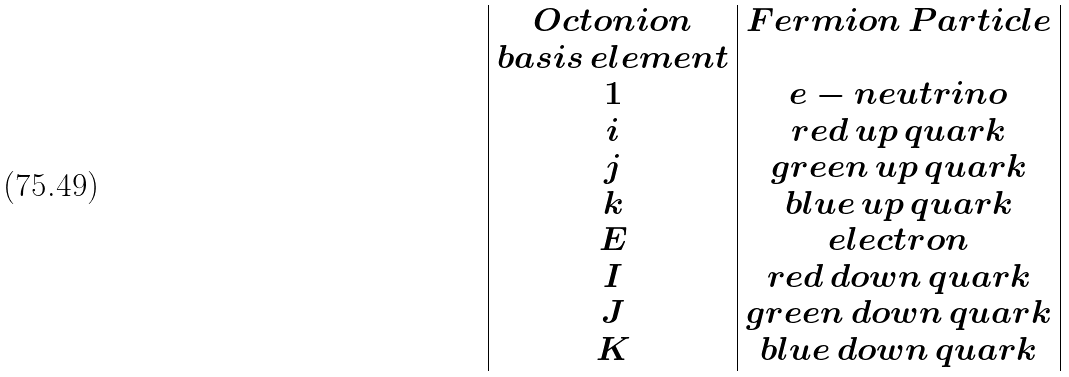<formula> <loc_0><loc_0><loc_500><loc_500>\begin{array} { | c | c | } O c t o n i o n & F e r m i o n \, P a r t i c l e \\ b a s i s \, e l e m e n t & \\ 1 & e - n e u t r i n o \\ i & r e d \, u p \, q u a r k \\ j & g r e e n \, u p \, q u a r k \\ k & b l u e \, u p \, q u a r k \\ E & e l e c t r o n \\ I & r e d \, d o w n \, q u a r k \\ J & g r e e n \, d o w n \, q u a r k \\ K & b l u e \, d o w n \, q u a r k \\ \end{array}</formula> 